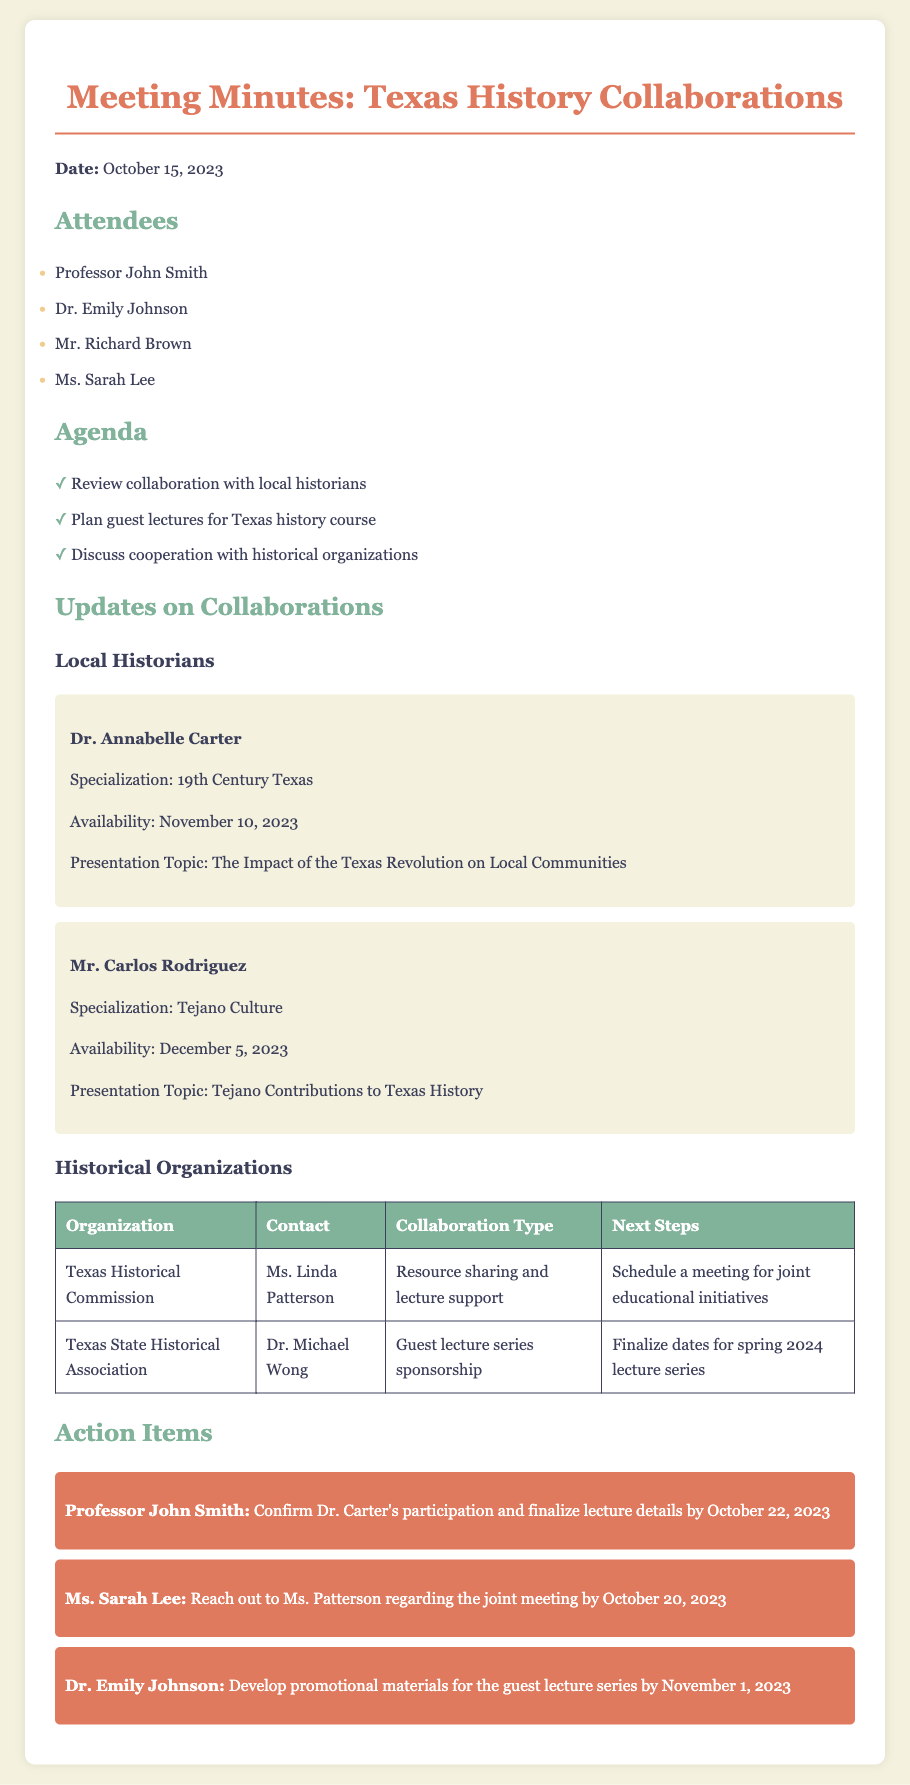What is the date of the meeting? The date of the meeting is explicitly stated at the top of the document.
Answer: October 15, 2023 Who is giving a presentation on the impact of the Texas Revolution? This information is provided in the section about local historians, naming the presenter and their topic.
Answer: Dr. Annabelle Carter What is the availability date for Mr. Carlos Rodriguez? The availability date for this local historian is mentioned in the update section.
Answer: December 5, 2023 What is the collaboration type with the Texas Historical Commission? This is listed in the table under the type of collaboration with this organization.
Answer: Resource sharing and lecture support By what date should Professor John Smith confirm Dr. Carter's participation? The action item specifies the deadline for confirmation regarding the guest lecture.
Answer: October 22, 2023 What topic will Mr. Carlos Rodriguez present? This information is stated in the section on local historians under his name.
Answer: Tejano Contributions to Texas History Who is responsible for developing promotional materials? The action item section details who is tasked with this specific responsibility.
Answer: Dr. Emily Johnson What is the next step for the Texas State Historical Association? This next step is specified in the table under the section for that organization.
Answer: Finalize dates for spring 2024 lecture series 